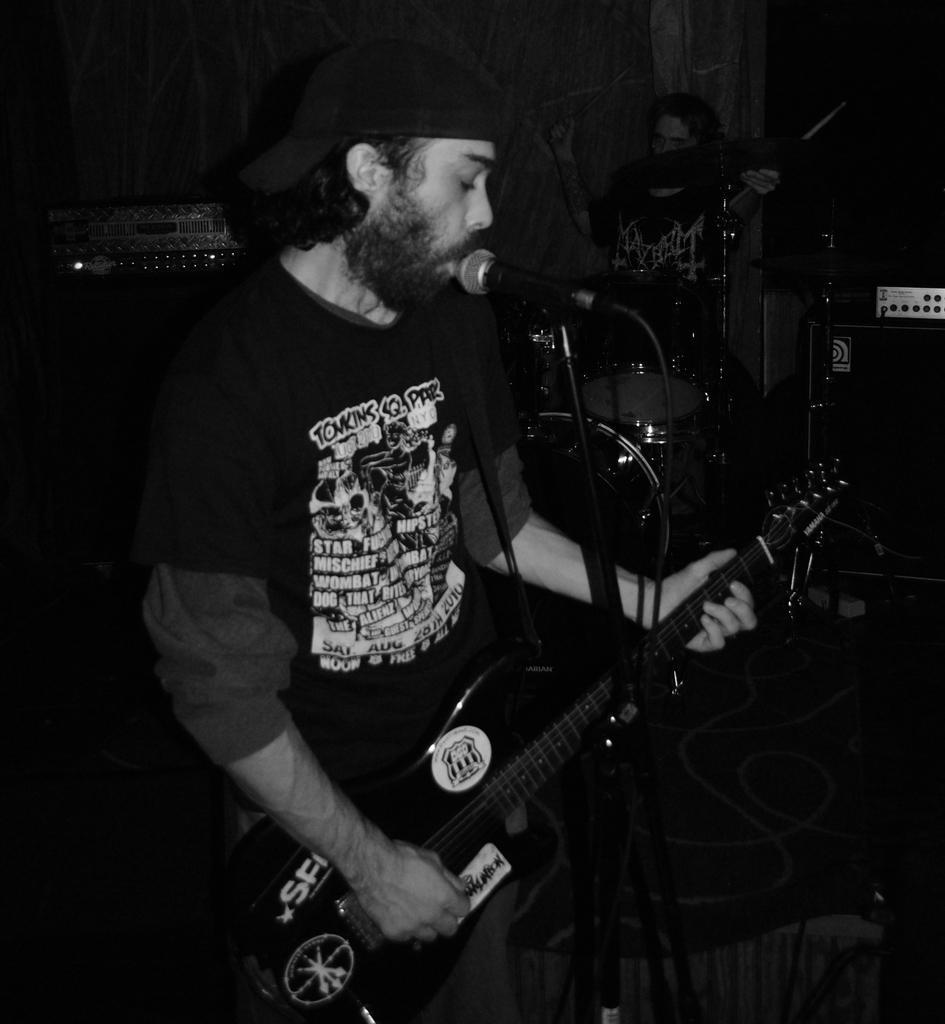Please provide a concise description of this image. Here we can see a man playing a guitar and singing a song with a microphone in front of him and beside him we can see a person playing drums 